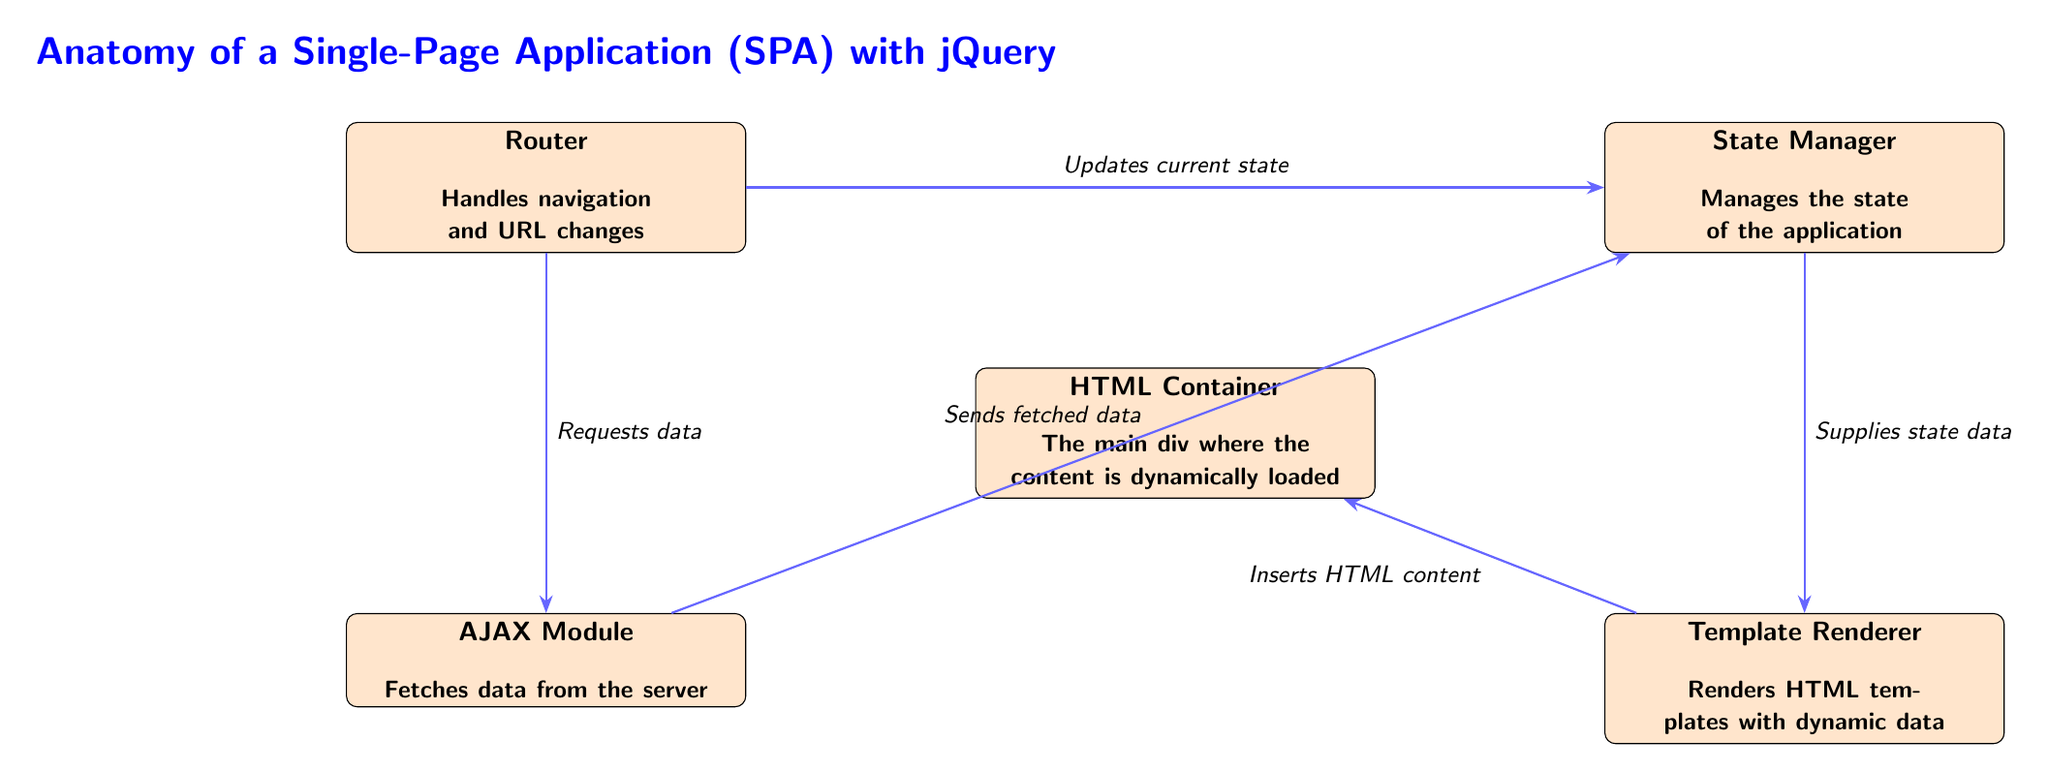What is the main container for dynamically loaded content? The diagram labels the main container as the "HTML Container," which is where the content of the single-page application is displayed.
Answer: HTML Container How many components are in this SPA architecture? The diagram displays a total of five components: Router, State Manager, AJAX Module, Template Renderer, and HTML Container.
Answer: Five Which component handles navigation and URL changes? According to the diagram, the component responsible for handling navigation and URL changes is labeled as the "Router."
Answer: Router What does the AJAX Module do? The diagram clearly indicates that the AJAX Module is tasked with fetching data from the server.
Answer: Fetches data from the server What relationship exists between the Router and the State Manager? The diagram shows that the Router updates the current state, which indicates a direct relationship where the Router influences the State Manager.
Answer: Updates current state Which component receives the state data from the State Manager? From the diagram, it can be seen that the Template Renderer is the component that receives the state data provided by the State Manager.
Answer: Template Renderer How does the Router interact with the AJAX Module? The diagram specifies that the Router requests data from the AJAX Module, indicating a direct request made by the Router to this module.
Answer: Requests data What is the last action performed in the flow of this SPA? According to the flow in the diagram, the last action performed is the insertion of HTML content into the HTML Container by the Template Renderer.
Answer: Inserts HTML content Which module sends fetched data to the State Manager? The diagram details that the AJAX Module is responsible for sending the fetched data to the State Manager.
Answer: AJAX Module 